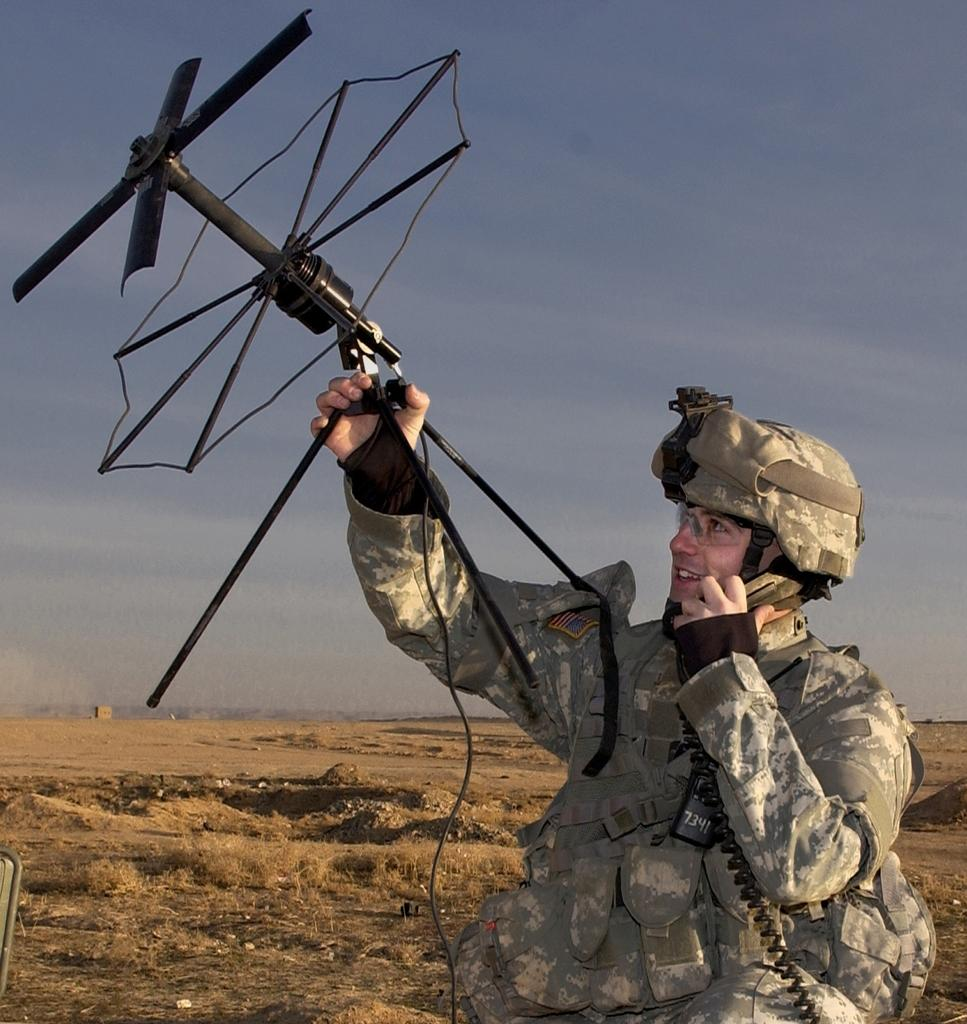What is present in the image? There is a person in the image. What is the person holding? The person is holding an object. What can be seen on the ground in the background of the image? There is grass on the ground in the background of the image. What is visible in the sky in the background of the image? The sky is visible in the background of the image. What type of noise can be heard coming from the dog in the image? There is no dog present in the image, so no noise can be heard from a dog. 